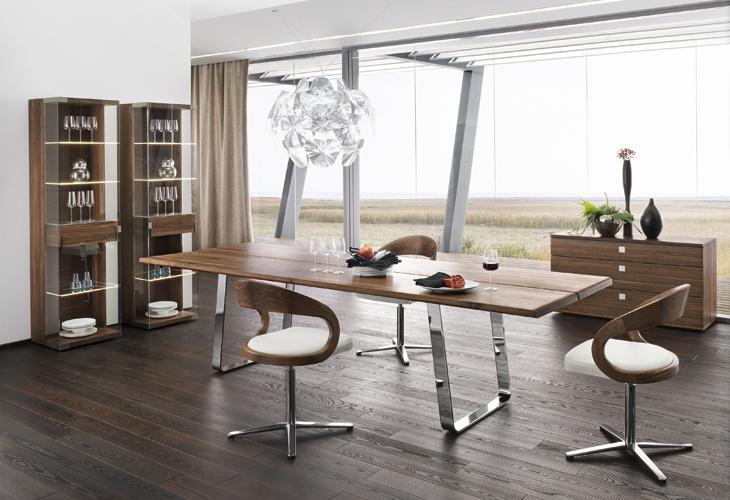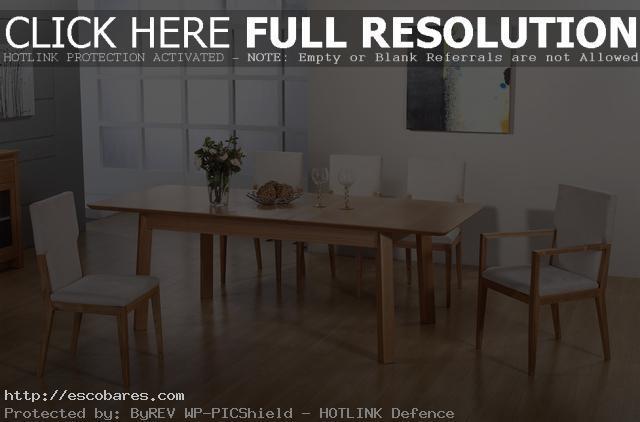The first image is the image on the left, the second image is the image on the right. For the images shown, is this caption "In one image, a rectangular table has long bench seating on one side." true? Answer yes or no. No. 